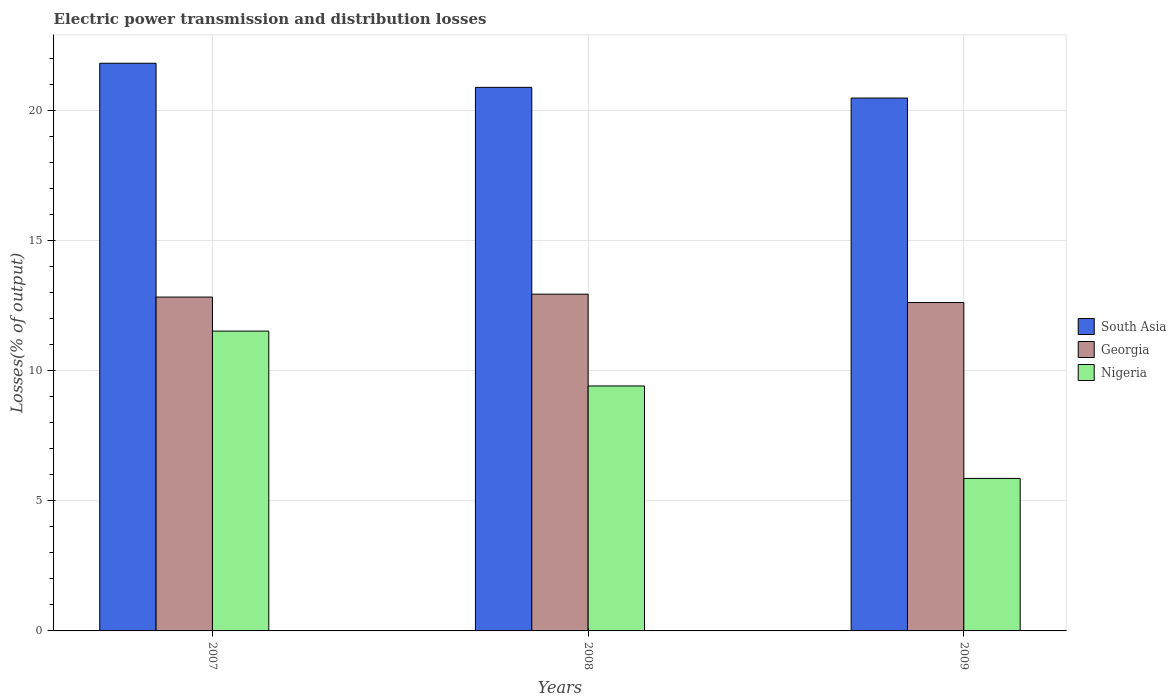How many different coloured bars are there?
Your response must be concise. 3. How many groups of bars are there?
Offer a very short reply. 3. Are the number of bars on each tick of the X-axis equal?
Your answer should be compact. Yes. How many bars are there on the 2nd tick from the left?
Provide a short and direct response. 3. What is the label of the 3rd group of bars from the left?
Offer a very short reply. 2009. What is the electric power transmission and distribution losses in Georgia in 2008?
Keep it short and to the point. 12.95. Across all years, what is the maximum electric power transmission and distribution losses in Nigeria?
Make the answer very short. 11.53. Across all years, what is the minimum electric power transmission and distribution losses in Georgia?
Provide a succinct answer. 12.63. What is the total electric power transmission and distribution losses in South Asia in the graph?
Make the answer very short. 63.24. What is the difference between the electric power transmission and distribution losses in Georgia in 2007 and that in 2009?
Offer a terse response. 0.21. What is the difference between the electric power transmission and distribution losses in Nigeria in 2007 and the electric power transmission and distribution losses in South Asia in 2009?
Offer a terse response. -8.96. What is the average electric power transmission and distribution losses in South Asia per year?
Provide a succinct answer. 21.08. In the year 2007, what is the difference between the electric power transmission and distribution losses in South Asia and electric power transmission and distribution losses in Nigeria?
Keep it short and to the point. 10.3. What is the ratio of the electric power transmission and distribution losses in Georgia in 2007 to that in 2009?
Make the answer very short. 1.02. Is the electric power transmission and distribution losses in Georgia in 2007 less than that in 2009?
Ensure brevity in your answer.  No. What is the difference between the highest and the second highest electric power transmission and distribution losses in Georgia?
Provide a short and direct response. 0.11. What is the difference between the highest and the lowest electric power transmission and distribution losses in South Asia?
Ensure brevity in your answer.  1.34. What does the 1st bar from the left in 2008 represents?
Your response must be concise. South Asia. What does the 2nd bar from the right in 2007 represents?
Your answer should be very brief. Georgia. Is it the case that in every year, the sum of the electric power transmission and distribution losses in Georgia and electric power transmission and distribution losses in South Asia is greater than the electric power transmission and distribution losses in Nigeria?
Provide a succinct answer. Yes. How many bars are there?
Your answer should be very brief. 9. Are all the bars in the graph horizontal?
Your response must be concise. No. Does the graph contain any zero values?
Your response must be concise. No. Does the graph contain grids?
Offer a very short reply. Yes. Where does the legend appear in the graph?
Make the answer very short. Center right. What is the title of the graph?
Make the answer very short. Electric power transmission and distribution losses. Does "Haiti" appear as one of the legend labels in the graph?
Your answer should be very brief. No. What is the label or title of the Y-axis?
Your answer should be very brief. Losses(% of output). What is the Losses(% of output) of South Asia in 2007?
Your answer should be very brief. 21.84. What is the Losses(% of output) in Georgia in 2007?
Your answer should be compact. 12.84. What is the Losses(% of output) in Nigeria in 2007?
Offer a terse response. 11.53. What is the Losses(% of output) of South Asia in 2008?
Keep it short and to the point. 20.91. What is the Losses(% of output) of Georgia in 2008?
Your answer should be compact. 12.95. What is the Losses(% of output) of Nigeria in 2008?
Keep it short and to the point. 9.42. What is the Losses(% of output) in South Asia in 2009?
Your answer should be very brief. 20.5. What is the Losses(% of output) of Georgia in 2009?
Offer a terse response. 12.63. What is the Losses(% of output) of Nigeria in 2009?
Your answer should be compact. 5.87. Across all years, what is the maximum Losses(% of output) in South Asia?
Your answer should be very brief. 21.84. Across all years, what is the maximum Losses(% of output) of Georgia?
Give a very brief answer. 12.95. Across all years, what is the maximum Losses(% of output) of Nigeria?
Provide a short and direct response. 11.53. Across all years, what is the minimum Losses(% of output) of South Asia?
Your answer should be very brief. 20.5. Across all years, what is the minimum Losses(% of output) in Georgia?
Make the answer very short. 12.63. Across all years, what is the minimum Losses(% of output) of Nigeria?
Offer a terse response. 5.87. What is the total Losses(% of output) in South Asia in the graph?
Your response must be concise. 63.24. What is the total Losses(% of output) in Georgia in the graph?
Your response must be concise. 38.43. What is the total Losses(% of output) of Nigeria in the graph?
Provide a succinct answer. 26.82. What is the difference between the Losses(% of output) in South Asia in 2007 and that in 2008?
Offer a very short reply. 0.93. What is the difference between the Losses(% of output) in Georgia in 2007 and that in 2008?
Provide a succinct answer. -0.11. What is the difference between the Losses(% of output) in Nigeria in 2007 and that in 2008?
Make the answer very short. 2.11. What is the difference between the Losses(% of output) of South Asia in 2007 and that in 2009?
Offer a very short reply. 1.34. What is the difference between the Losses(% of output) of Georgia in 2007 and that in 2009?
Ensure brevity in your answer.  0.21. What is the difference between the Losses(% of output) of Nigeria in 2007 and that in 2009?
Offer a very short reply. 5.67. What is the difference between the Losses(% of output) in South Asia in 2008 and that in 2009?
Provide a succinct answer. 0.41. What is the difference between the Losses(% of output) of Georgia in 2008 and that in 2009?
Ensure brevity in your answer.  0.32. What is the difference between the Losses(% of output) in Nigeria in 2008 and that in 2009?
Make the answer very short. 3.56. What is the difference between the Losses(% of output) in South Asia in 2007 and the Losses(% of output) in Georgia in 2008?
Your response must be concise. 8.88. What is the difference between the Losses(% of output) of South Asia in 2007 and the Losses(% of output) of Nigeria in 2008?
Ensure brevity in your answer.  12.41. What is the difference between the Losses(% of output) in Georgia in 2007 and the Losses(% of output) in Nigeria in 2008?
Make the answer very short. 3.42. What is the difference between the Losses(% of output) in South Asia in 2007 and the Losses(% of output) in Georgia in 2009?
Your answer should be very brief. 9.2. What is the difference between the Losses(% of output) of South Asia in 2007 and the Losses(% of output) of Nigeria in 2009?
Provide a succinct answer. 15.97. What is the difference between the Losses(% of output) of Georgia in 2007 and the Losses(% of output) of Nigeria in 2009?
Give a very brief answer. 6.98. What is the difference between the Losses(% of output) in South Asia in 2008 and the Losses(% of output) in Georgia in 2009?
Give a very brief answer. 8.28. What is the difference between the Losses(% of output) in South Asia in 2008 and the Losses(% of output) in Nigeria in 2009?
Make the answer very short. 15.04. What is the difference between the Losses(% of output) in Georgia in 2008 and the Losses(% of output) in Nigeria in 2009?
Keep it short and to the point. 7.09. What is the average Losses(% of output) of South Asia per year?
Make the answer very short. 21.08. What is the average Losses(% of output) in Georgia per year?
Keep it short and to the point. 12.81. What is the average Losses(% of output) of Nigeria per year?
Offer a very short reply. 8.94. In the year 2007, what is the difference between the Losses(% of output) in South Asia and Losses(% of output) in Georgia?
Your answer should be very brief. 8.99. In the year 2007, what is the difference between the Losses(% of output) of South Asia and Losses(% of output) of Nigeria?
Your response must be concise. 10.3. In the year 2007, what is the difference between the Losses(% of output) in Georgia and Losses(% of output) in Nigeria?
Offer a terse response. 1.31. In the year 2008, what is the difference between the Losses(% of output) of South Asia and Losses(% of output) of Georgia?
Provide a short and direct response. 7.95. In the year 2008, what is the difference between the Losses(% of output) of South Asia and Losses(% of output) of Nigeria?
Offer a very short reply. 11.49. In the year 2008, what is the difference between the Losses(% of output) of Georgia and Losses(% of output) of Nigeria?
Make the answer very short. 3.53. In the year 2009, what is the difference between the Losses(% of output) in South Asia and Losses(% of output) in Georgia?
Your response must be concise. 7.87. In the year 2009, what is the difference between the Losses(% of output) in South Asia and Losses(% of output) in Nigeria?
Make the answer very short. 14.63. In the year 2009, what is the difference between the Losses(% of output) of Georgia and Losses(% of output) of Nigeria?
Offer a terse response. 6.77. What is the ratio of the Losses(% of output) in South Asia in 2007 to that in 2008?
Ensure brevity in your answer.  1.04. What is the ratio of the Losses(% of output) in Nigeria in 2007 to that in 2008?
Ensure brevity in your answer.  1.22. What is the ratio of the Losses(% of output) of South Asia in 2007 to that in 2009?
Keep it short and to the point. 1.07. What is the ratio of the Losses(% of output) in Georgia in 2007 to that in 2009?
Your response must be concise. 1.02. What is the ratio of the Losses(% of output) of Nigeria in 2007 to that in 2009?
Give a very brief answer. 1.97. What is the ratio of the Losses(% of output) in South Asia in 2008 to that in 2009?
Ensure brevity in your answer.  1.02. What is the ratio of the Losses(% of output) in Georgia in 2008 to that in 2009?
Your response must be concise. 1.03. What is the ratio of the Losses(% of output) in Nigeria in 2008 to that in 2009?
Your answer should be very brief. 1.61. What is the difference between the highest and the second highest Losses(% of output) in South Asia?
Keep it short and to the point. 0.93. What is the difference between the highest and the second highest Losses(% of output) of Georgia?
Keep it short and to the point. 0.11. What is the difference between the highest and the second highest Losses(% of output) in Nigeria?
Keep it short and to the point. 2.11. What is the difference between the highest and the lowest Losses(% of output) of South Asia?
Give a very brief answer. 1.34. What is the difference between the highest and the lowest Losses(% of output) of Georgia?
Your answer should be compact. 0.32. What is the difference between the highest and the lowest Losses(% of output) of Nigeria?
Give a very brief answer. 5.67. 